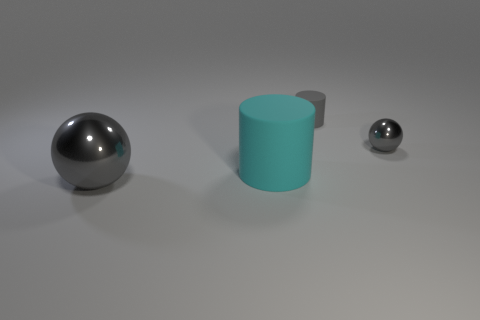There is a metal ball that is the same color as the tiny metallic object; what is its size?
Offer a terse response. Large. What number of big spheres are the same color as the small metal ball?
Your answer should be compact. 1. How many other things are the same size as the gray rubber cylinder?
Offer a terse response. 1. How big is the object that is both to the right of the big gray object and to the left of the small gray matte object?
Keep it short and to the point. Large. How many small metal objects have the same shape as the big cyan object?
Provide a succinct answer. 0. What material is the small cylinder?
Your answer should be compact. Rubber. Is the big cyan matte object the same shape as the big shiny thing?
Provide a succinct answer. No. Is there a green object that has the same material as the big gray ball?
Offer a terse response. No. What is the color of the object that is right of the big cyan matte cylinder and in front of the gray cylinder?
Your answer should be compact. Gray. There is a cylinder behind the big cyan rubber cylinder; what is its material?
Your answer should be very brief. Rubber. 